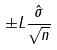Convert formula to latex. <formula><loc_0><loc_0><loc_500><loc_500>\pm L \frac { \hat { \sigma } } { \sqrt { n } }</formula> 